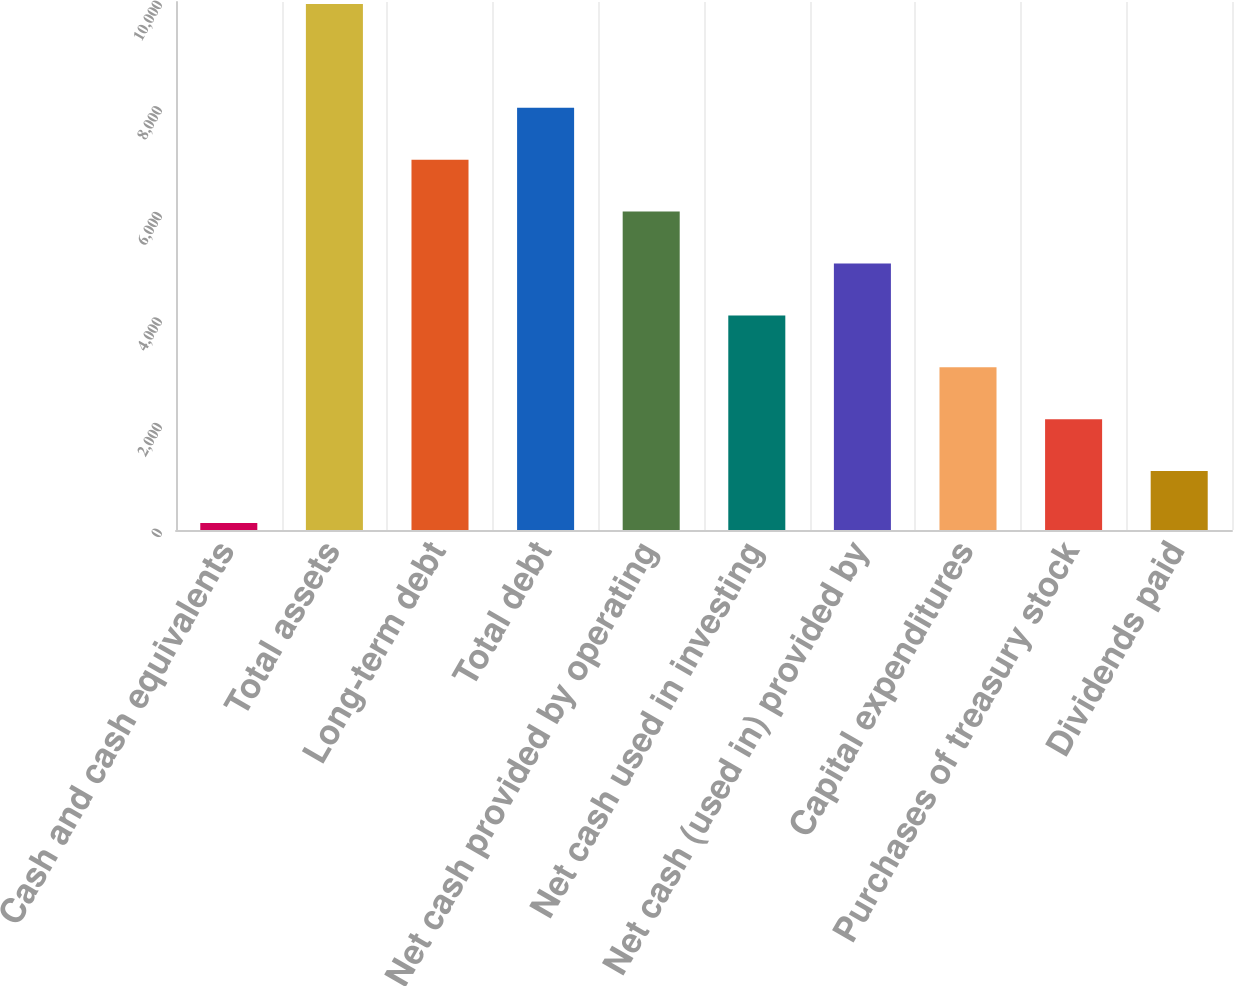Convert chart. <chart><loc_0><loc_0><loc_500><loc_500><bar_chart><fcel>Cash and cash equivalents<fcel>Total assets<fcel>Long-term debt<fcel>Total debt<fcel>Net cash provided by operating<fcel>Net cash used in investing<fcel>Net cash (used in) provided by<fcel>Capital expenditures<fcel>Purchases of treasury stock<fcel>Dividends paid<nl><fcel>133<fcel>9962<fcel>7013.3<fcel>7996.2<fcel>6030.4<fcel>4064.6<fcel>5047.5<fcel>3081.7<fcel>2098.8<fcel>1115.9<nl></chart> 